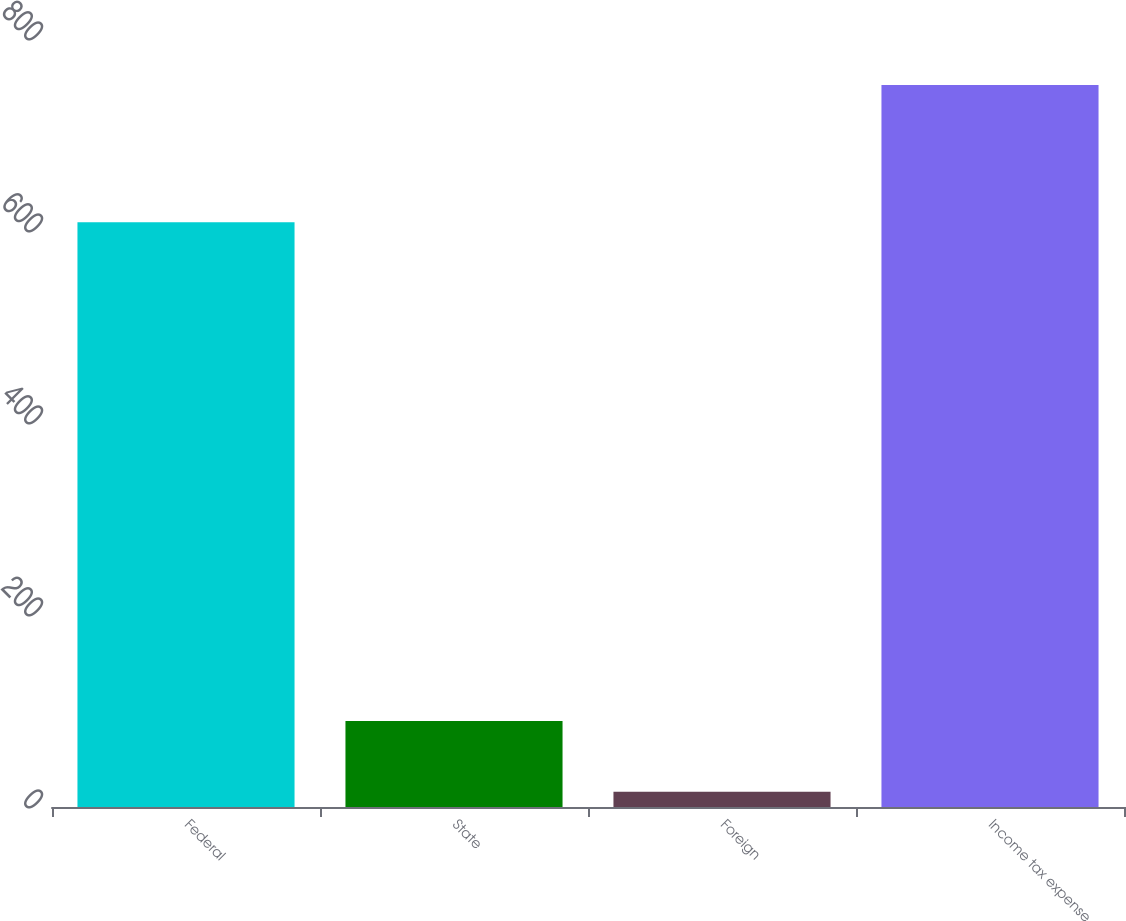Convert chart. <chart><loc_0><loc_0><loc_500><loc_500><bar_chart><fcel>Federal<fcel>State<fcel>Foreign<fcel>Income tax expense<nl><fcel>609<fcel>89.6<fcel>16<fcel>752<nl></chart> 